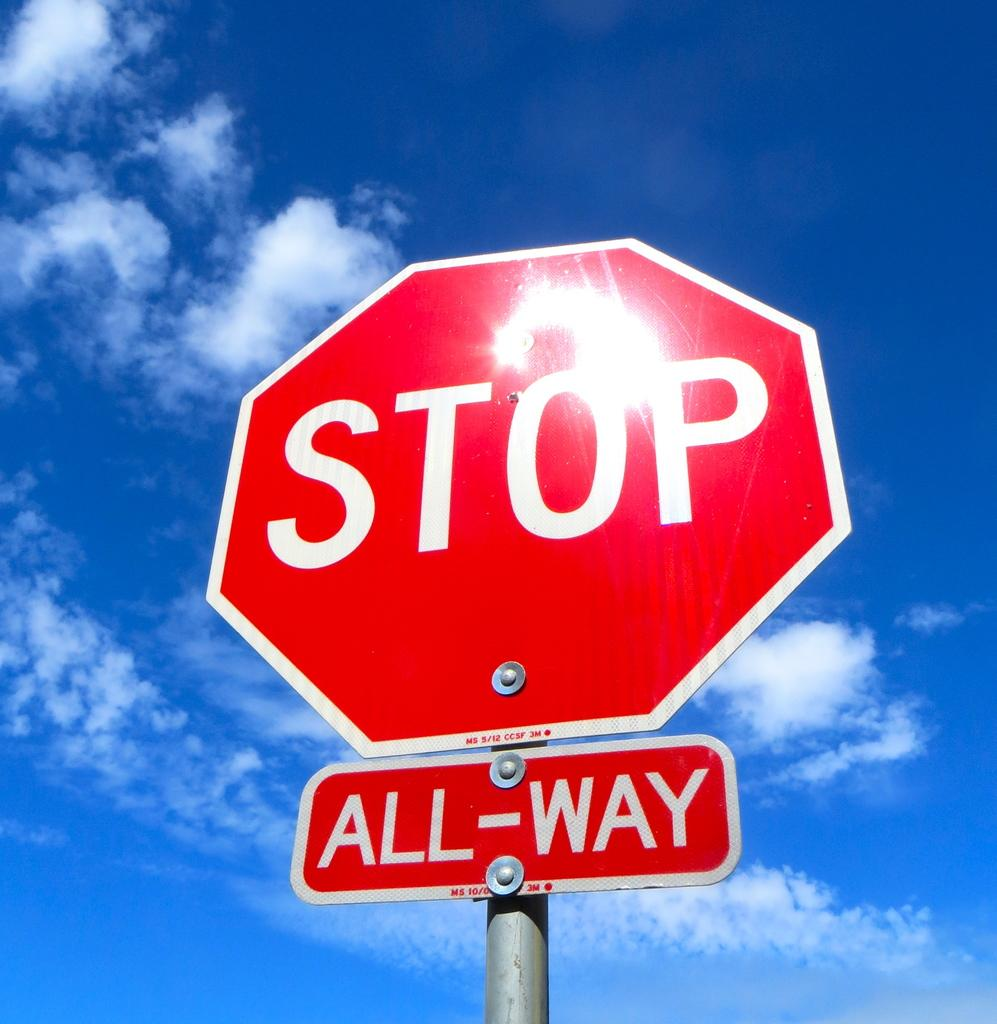<image>
Share a concise interpretation of the image provided. A red and white stop sign has a smaller sign that reads all way beneath it. 